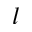Convert formula to latex. <formula><loc_0><loc_0><loc_500><loc_500>l</formula> 